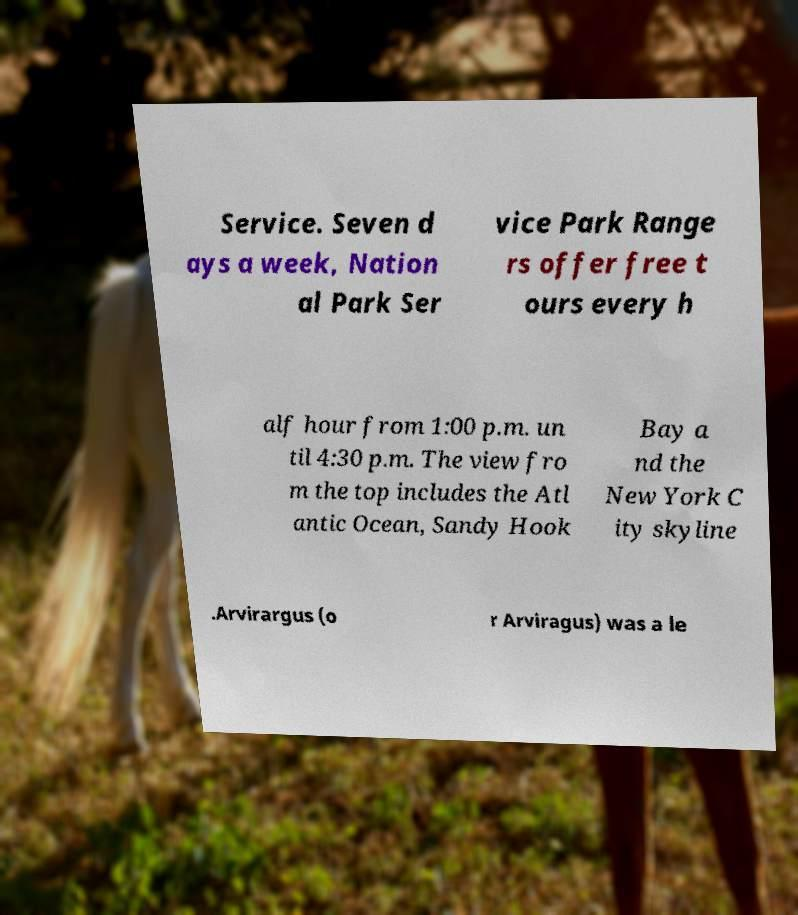What messages or text are displayed in this image? I need them in a readable, typed format. Service. Seven d ays a week, Nation al Park Ser vice Park Range rs offer free t ours every h alf hour from 1:00 p.m. un til 4:30 p.m. The view fro m the top includes the Atl antic Ocean, Sandy Hook Bay a nd the New York C ity skyline .Arvirargus (o r Arviragus) was a le 